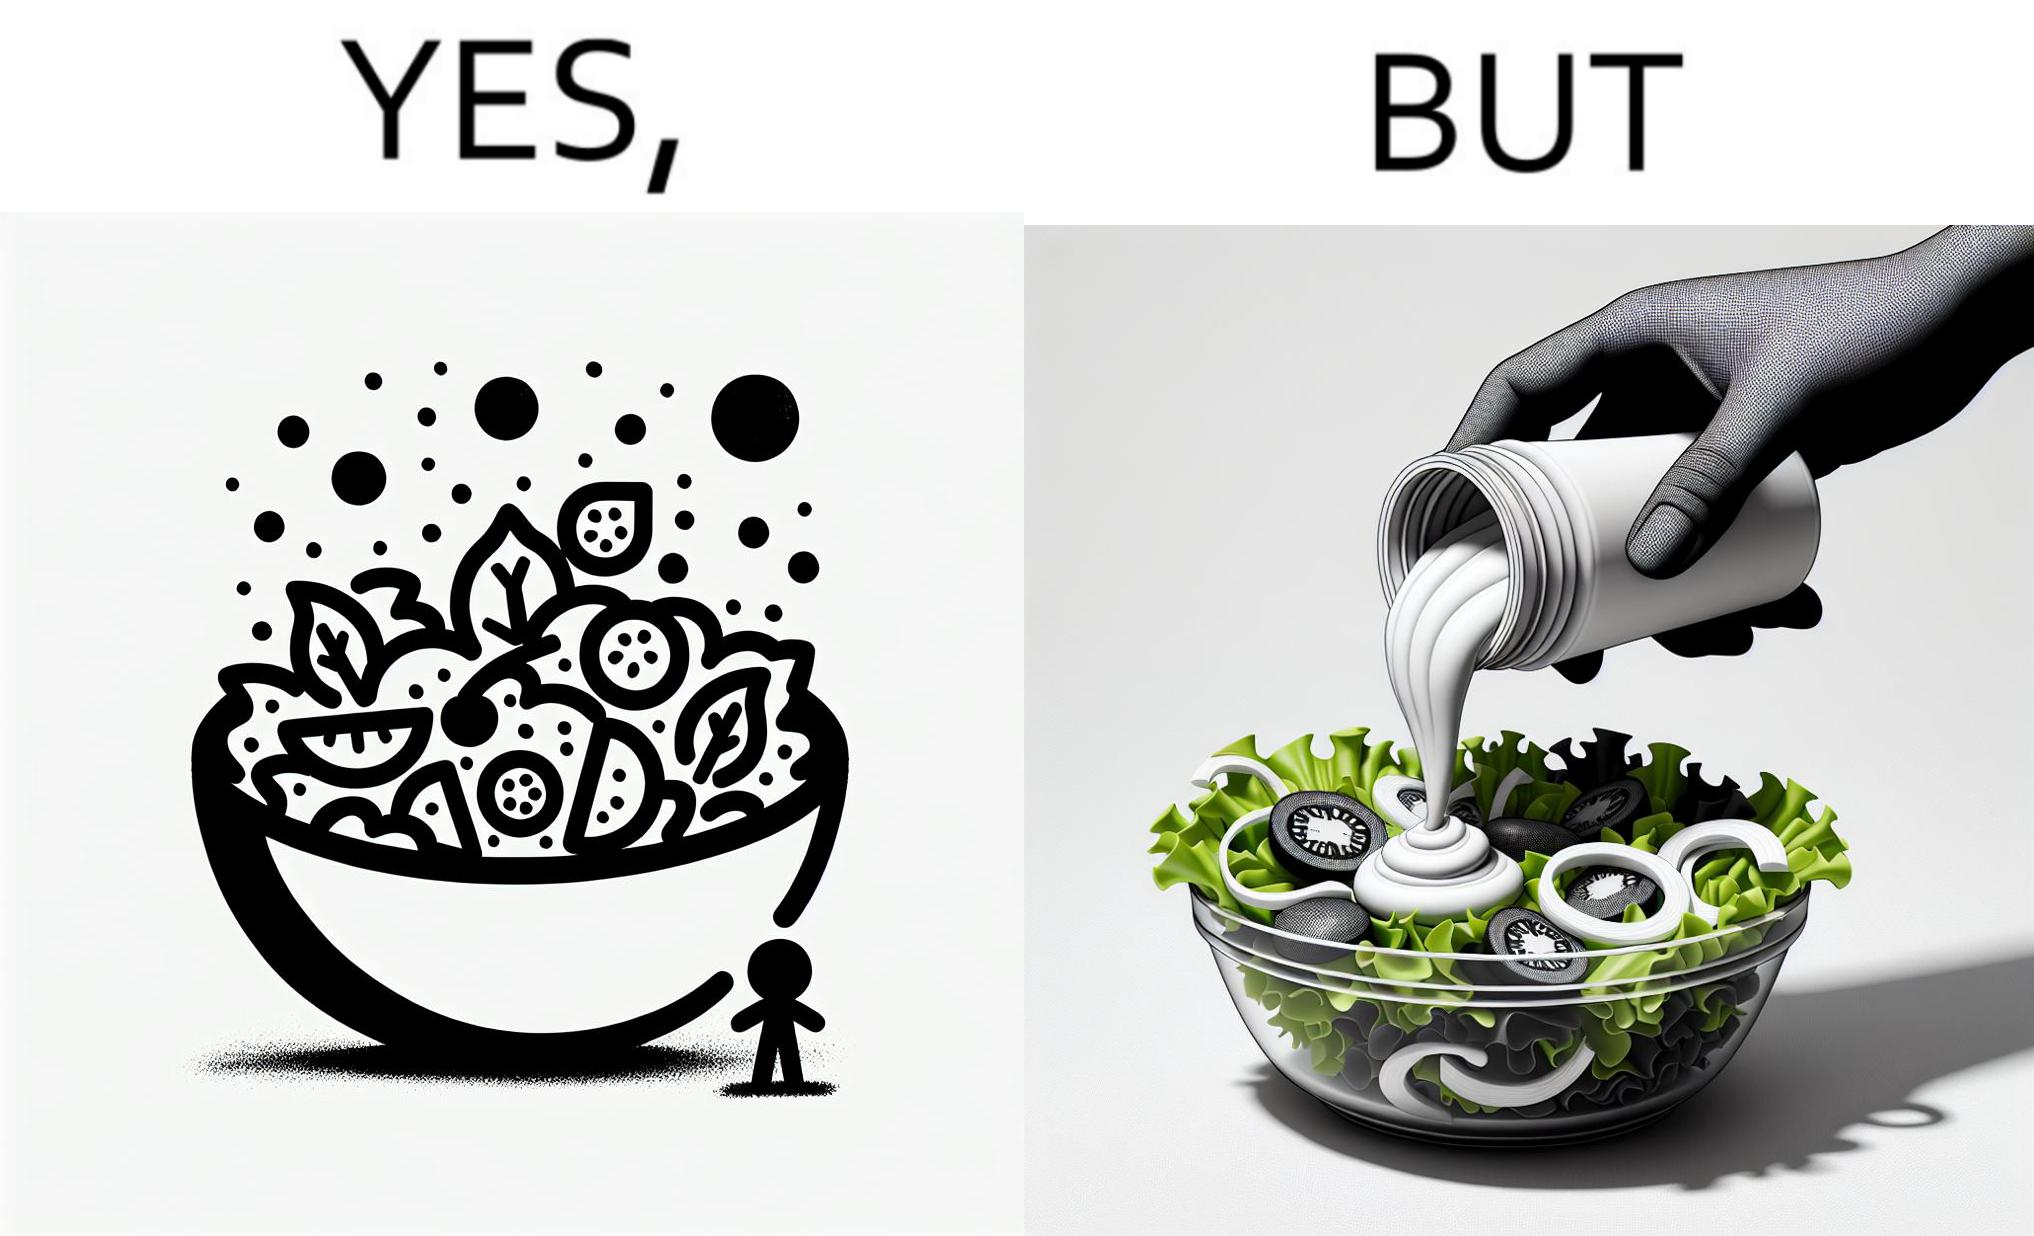Provide a description of this image. The image is ironical, as salad in a bowl by itself is very healthy. However, when people have it with Mayonnaise sauce to improve the taste, it is not healthy anymore, and defeats the point of having nutrient-rich salad altogether. 